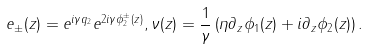<formula> <loc_0><loc_0><loc_500><loc_500>e _ { \pm } ( z ) = e ^ { i \gamma q _ { 2 } } e ^ { 2 i \gamma \phi _ { 2 } ^ { \pm } ( z ) } , \nu ( z ) = \frac { 1 } { \gamma } \left ( \eta \partial _ { z } \phi _ { 1 } ( z ) + i \partial _ { z } \phi _ { 2 } ( z ) \right ) .</formula> 